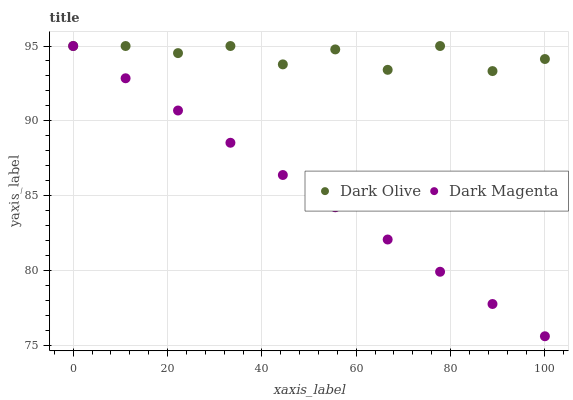Does Dark Magenta have the minimum area under the curve?
Answer yes or no. Yes. Does Dark Olive have the maximum area under the curve?
Answer yes or no. Yes. Does Dark Magenta have the maximum area under the curve?
Answer yes or no. No. Is Dark Magenta the smoothest?
Answer yes or no. Yes. Is Dark Olive the roughest?
Answer yes or no. Yes. Is Dark Magenta the roughest?
Answer yes or no. No. Does Dark Magenta have the lowest value?
Answer yes or no. Yes. Does Dark Magenta have the highest value?
Answer yes or no. Yes. Does Dark Olive intersect Dark Magenta?
Answer yes or no. Yes. Is Dark Olive less than Dark Magenta?
Answer yes or no. No. Is Dark Olive greater than Dark Magenta?
Answer yes or no. No. 